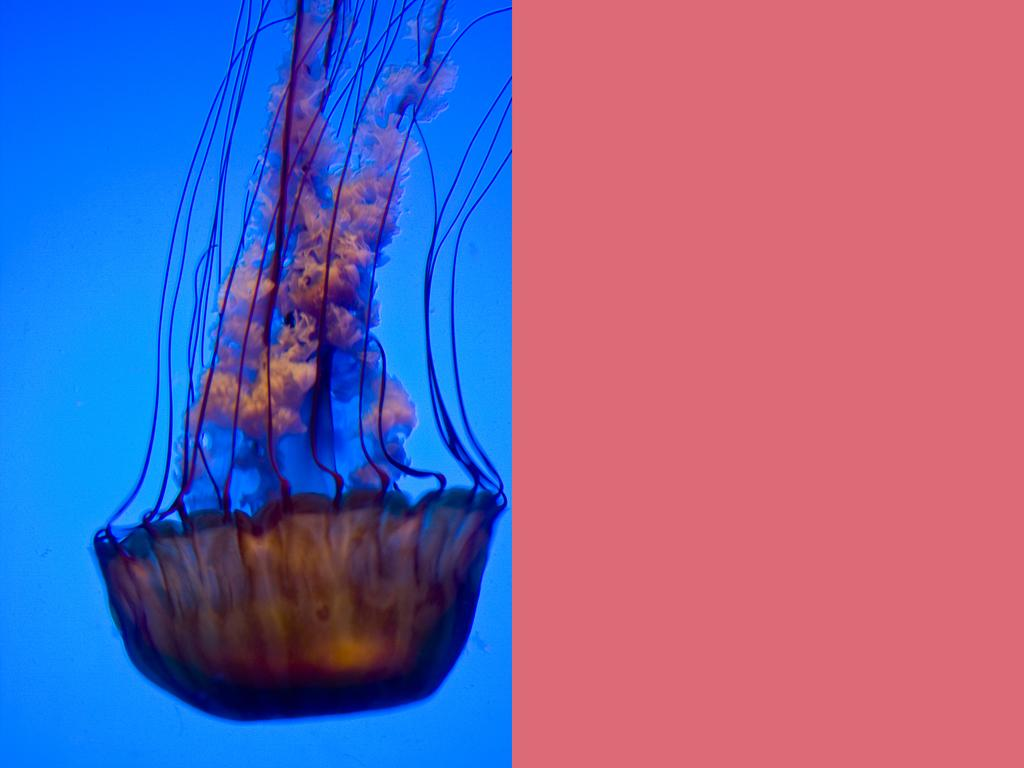What is the main subject of the image? There is a jellyfish in the image. What color is the background of the image? The jellyfish is on a blue background. What can be seen on the right side of the image? There is a pink surface on the right side of the image. What type of glove is being used in the argument in the image? There is no glove or argument present in the image; it features a jellyfish on a blue background with a pink surface on the right side. What is the kettle used for in the image? There is no kettle present in the image. 